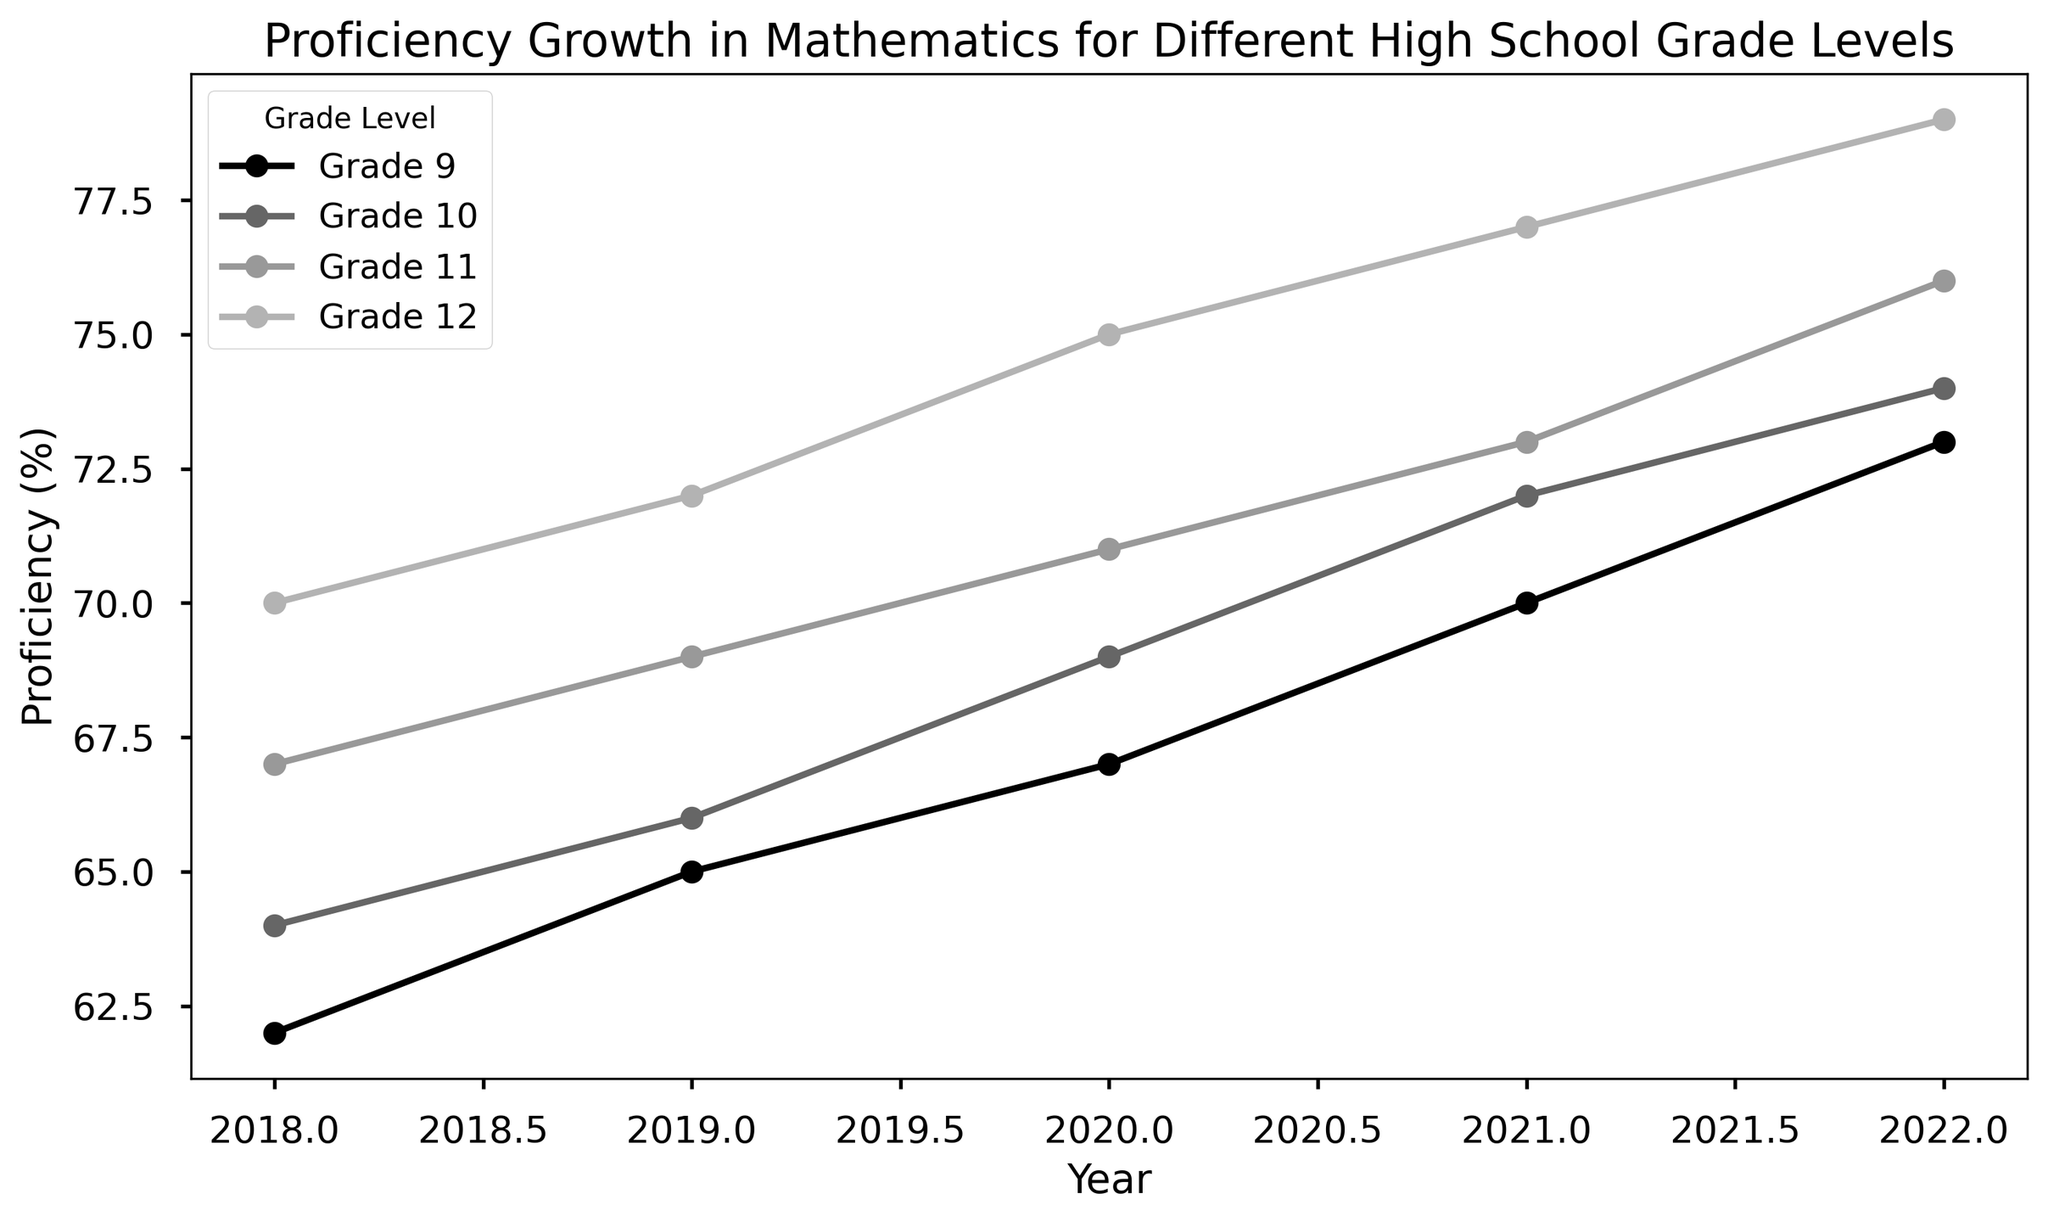What's the overall trend in proficiency levels for each grade? By observing the figure, look at the slope of the lines for each grade over the years. If the lines slope upwards, it means the proficiency level is increasing. Each grade's line shows a positive slope from 2018 to 2022.
Answer: Increasing Which grade achieved the highest proficiency in 2022? To determine the highest proficiency in 2022, compare the y-values for all grades at the year 2022. The grade with the highest y-value is Grade 12 at 79%.
Answer: Grade 12 How much did the proficiency level of Grade 11 increase from 2018 to 2022? To find the increase, subtract the 2018 value from the 2022 value for Grade 11. The proficiency level in 2018 is 67%, and in 2022 it is 76%, so the increase is 76% - 67% = 9%.
Answer: 9% Which two grades had the same proficiency level in any year, if any? Look at each year's data point for all grades and see if any two grades intersect on the graph. In 2018, the lines for Grades 9 and 10 both end up at the same point. The proficiency level for both is 64%.
Answer: Grades 9 and 10 in 2018 What's the average proficiency level of Grade 10 over the displayed years? Add up the proficiency values for Grade 10 for each year and divide by the number of years (5). (64 + 66 + 69 + 72 + 74) = 345, so 345 / 5 = 69%.
Answer: 69% Which grade showed the least change in proficiency between 2018 and 2022? Calculate the difference between 2018 and 2022 proficiency levels for each grade. The values are: Grade 9 (73-62=11%), Grade 10 (74-64=10%), Grade 11 (76-67=9%), Grade 12 (79-70=9%). Both Grade 11 and Grade 12 show the least change at 9%.
Answer: Grades 11 and 12 Which two consecutive grades have the smallest difference in proficiency in 2022? To find the smallest difference, subtract the proficiency levels of consecutive grades for 2022 and determine the smallest value. The differences are: 10th vs 9th (74-73 = 1%), 11th vs 10th (76-74 = 2%), 12th vs 11th (79-76 = 3%). The smallest difference is between Grades 9 and 10 at 1%.
Answer: Grades 9 and 10 On average, by how much does the proficiency level increase each year for Grade 12? To find the average yearly increase, subtract the proficiency level of 2018 from 2022 for Grade 12, then divide by the number of years minus one (2022-2018 = 4). (79-70 = 9) / 4 = 2.25%.
Answer: 2.25% 